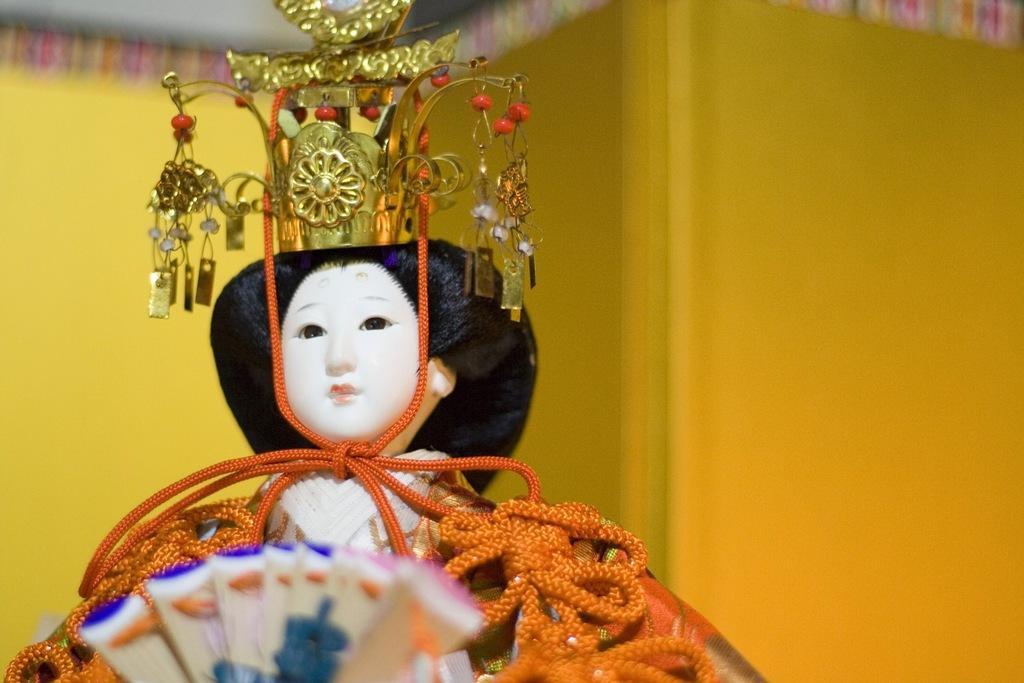How would you summarize this image in a sentence or two? In this picture we can see a doll with accessories. Behind the doll, there's a wall. 